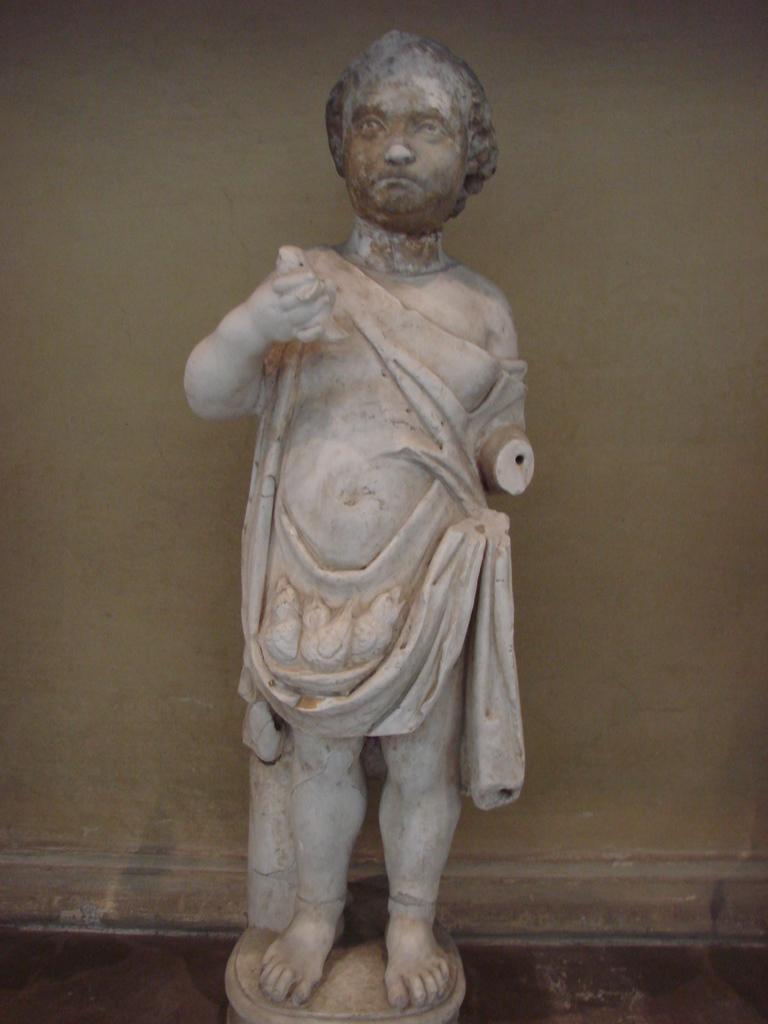Please provide a concise description of this image. In this image I can see a statue on the floor ,and at the back side is the wall. 